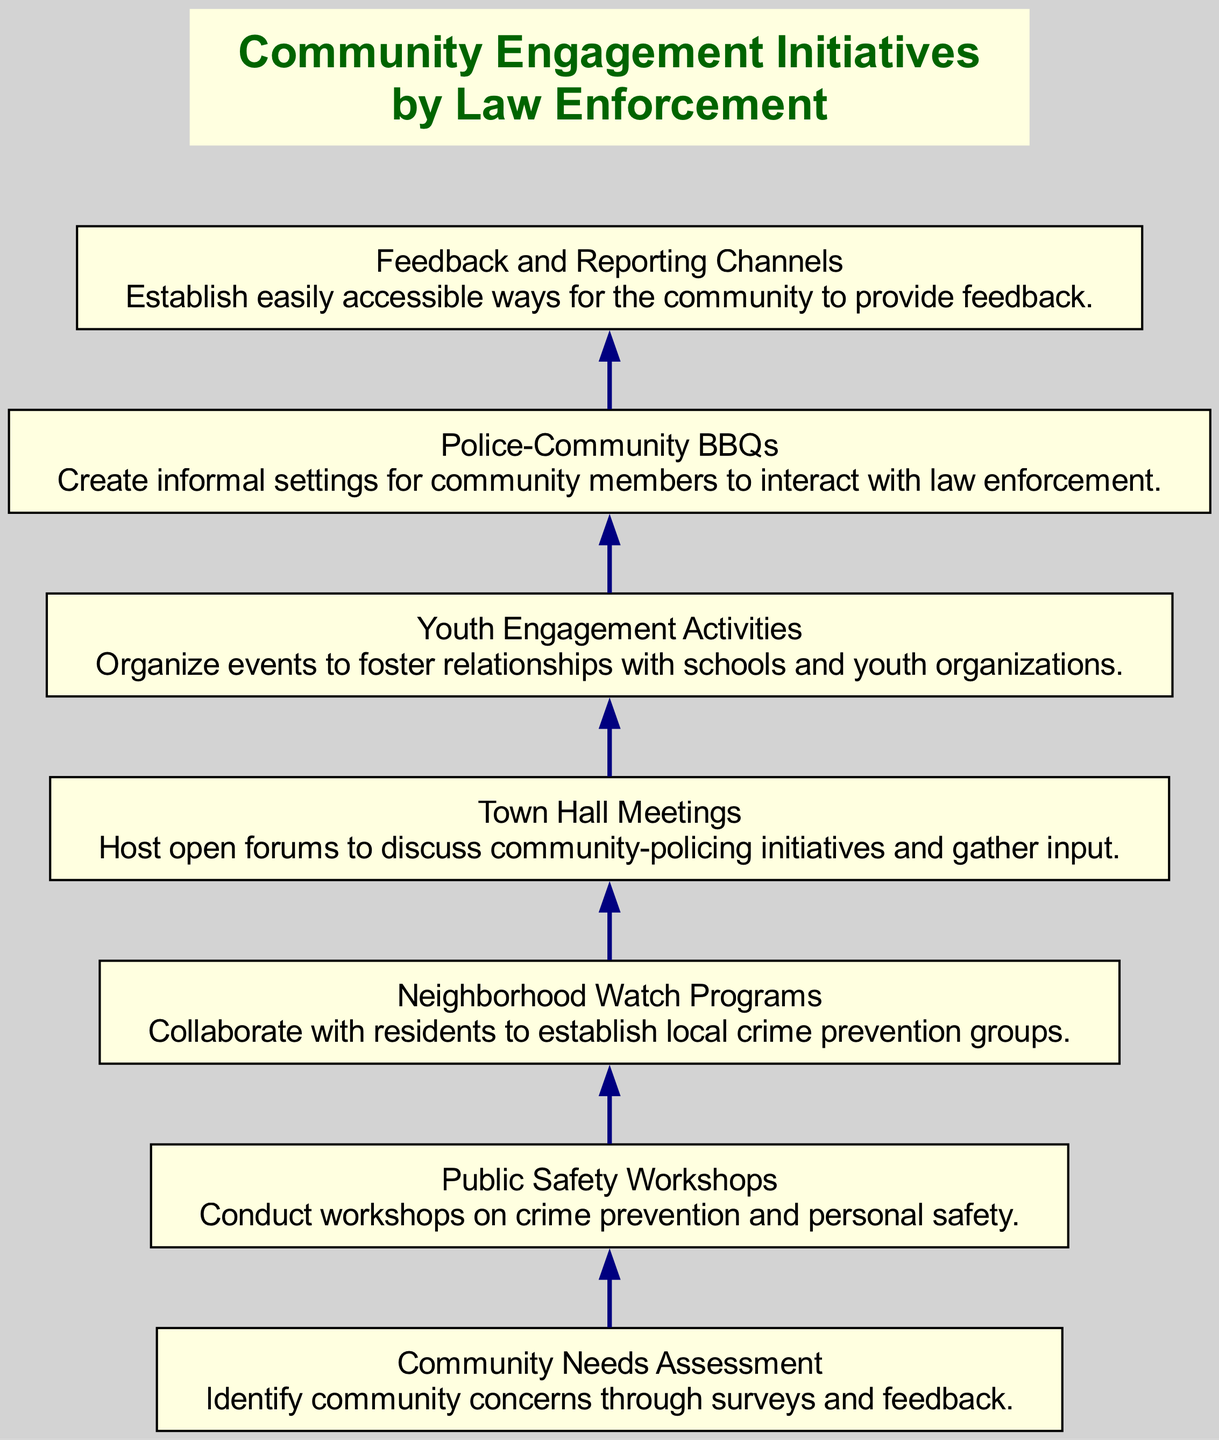What is the first node in the diagram? The first node in the diagram is "Community Needs Assessment", which is positioned at the top of the flow chart.
Answer: Community Needs Assessment How many nodes are present in the diagram? By counting the elements listed, there are a total of 7 nodes shown in the diagram, each representing a different community engagement initiative.
Answer: 7 Which node comes after "Youth Engagement Activities"? Following "Youth Engagement Activities" in the flow chart is the node "Police-Community BBQs", which is directly linked as the next step in the flow.
Answer: Police-Community BBQs What type of workshops are depicted in the diagram? The diagram illustrates "Public Safety Workshops", which focus specifically on crime prevention and personal safety, as described in the node.
Answer: Public Safety Workshops How many outreach initiatives are listed in the diagram? The outreach initiatives consist of "Neighborhood Watch Programs", "Town Hall Meetings", and "Police-Community BBQs", totaling 3 distinct outreach programs indicated in the flow.
Answer: 3 Which node serves as a feedback mechanism in the diagram? The node designated for feedback is "Feedback and Reporting Channels", where the community can easily provide their input regarding law enforcement.
Answer: Feedback and Reporting Channels From which node does the flow start? The flow begins at the "Community Needs Assessment", which identifies the community's concerns and sets the stage for subsequent initiatives.
Answer: Community Needs Assessment What is the last node in the diagram? The last node in the diagram is "Feedback and Reporting Channels", which is positioned at the end of the flow, emphasizing the importance of community input.
Answer: Feedback and Reporting Channels 